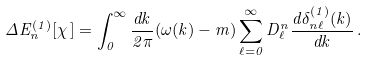<formula> <loc_0><loc_0><loc_500><loc_500>\Delta E ^ { ( 1 ) } _ { n } [ \chi \, ] = \int _ { 0 } ^ { \infty } \frac { d k } { 2 \pi } ( \omega ( k ) - m ) \sum _ { \ell = 0 } ^ { \infty } D _ { \ell } ^ { n } \frac { d \delta _ { n \ell } ^ { ( 1 ) } ( k ) } { d k } \, .</formula> 